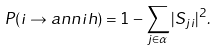<formula> <loc_0><loc_0><loc_500><loc_500>P ( i \rightarrow a n n i h ) = 1 - \sum _ { j \in \alpha } | S _ { j i } | ^ { 2 } .</formula> 